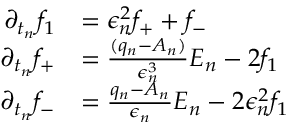<formula> <loc_0><loc_0><loc_500><loc_500>\begin{array} { r l } { \partial _ { t _ { n } } f _ { 1 } } & { = \epsilon _ { n } ^ { 2 } f _ { + } + f _ { - } } \\ { \partial _ { t _ { n } } f _ { + } } & { = \frac { ( q _ { n } - A _ { n } ) } { \epsilon _ { n } ^ { 3 } } E _ { n } - 2 f _ { 1 } } \\ { \partial _ { t _ { n } } f _ { - } } & { = \frac { q _ { n } - A _ { n } } { \epsilon _ { n } } E _ { n } - 2 \epsilon _ { n } ^ { 2 } f _ { 1 } } \end{array}</formula> 